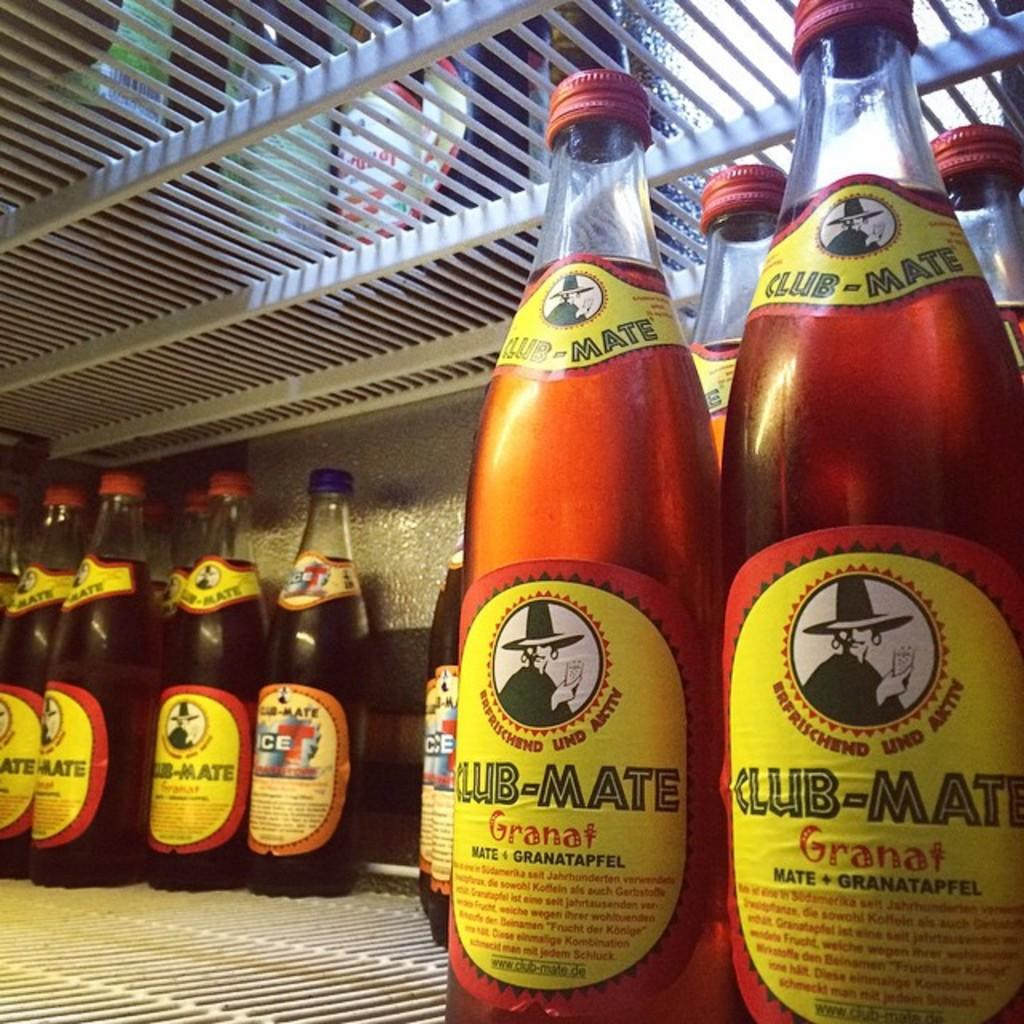<image>
Present a compact description of the photo's key features. Some bottles are labeled with the name CLUB-MATE on them. 